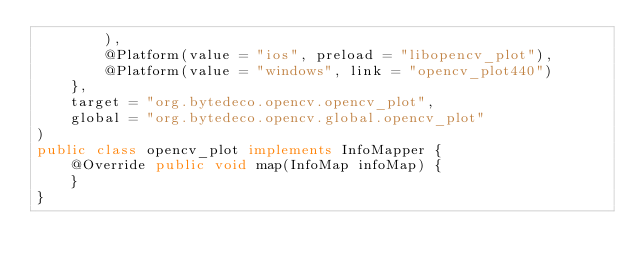<code> <loc_0><loc_0><loc_500><loc_500><_Java_>        ),
        @Platform(value = "ios", preload = "libopencv_plot"),
        @Platform(value = "windows", link = "opencv_plot440")
    },
    target = "org.bytedeco.opencv.opencv_plot",
    global = "org.bytedeco.opencv.global.opencv_plot"
)
public class opencv_plot implements InfoMapper {
    @Override public void map(InfoMap infoMap) {
    }
}
</code> 